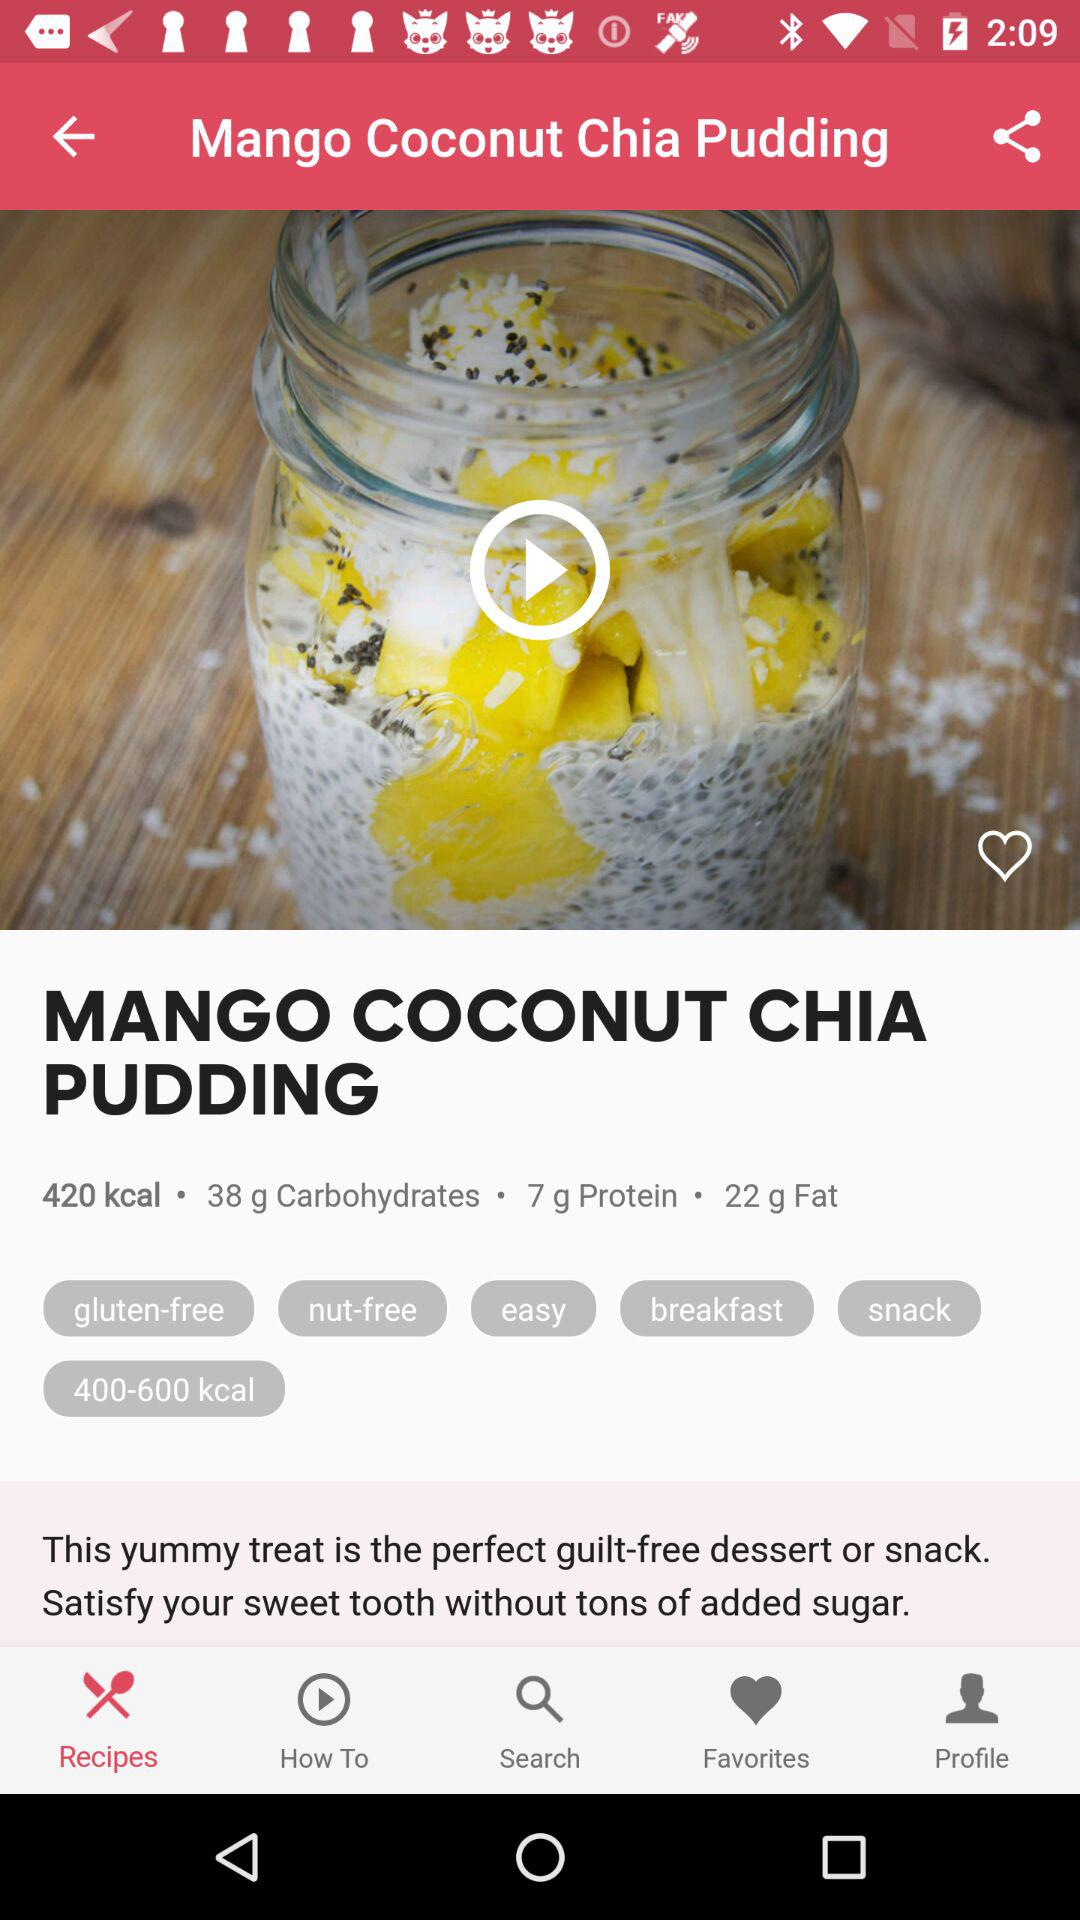Which tab is selected? The selected tab is "Recipes". 